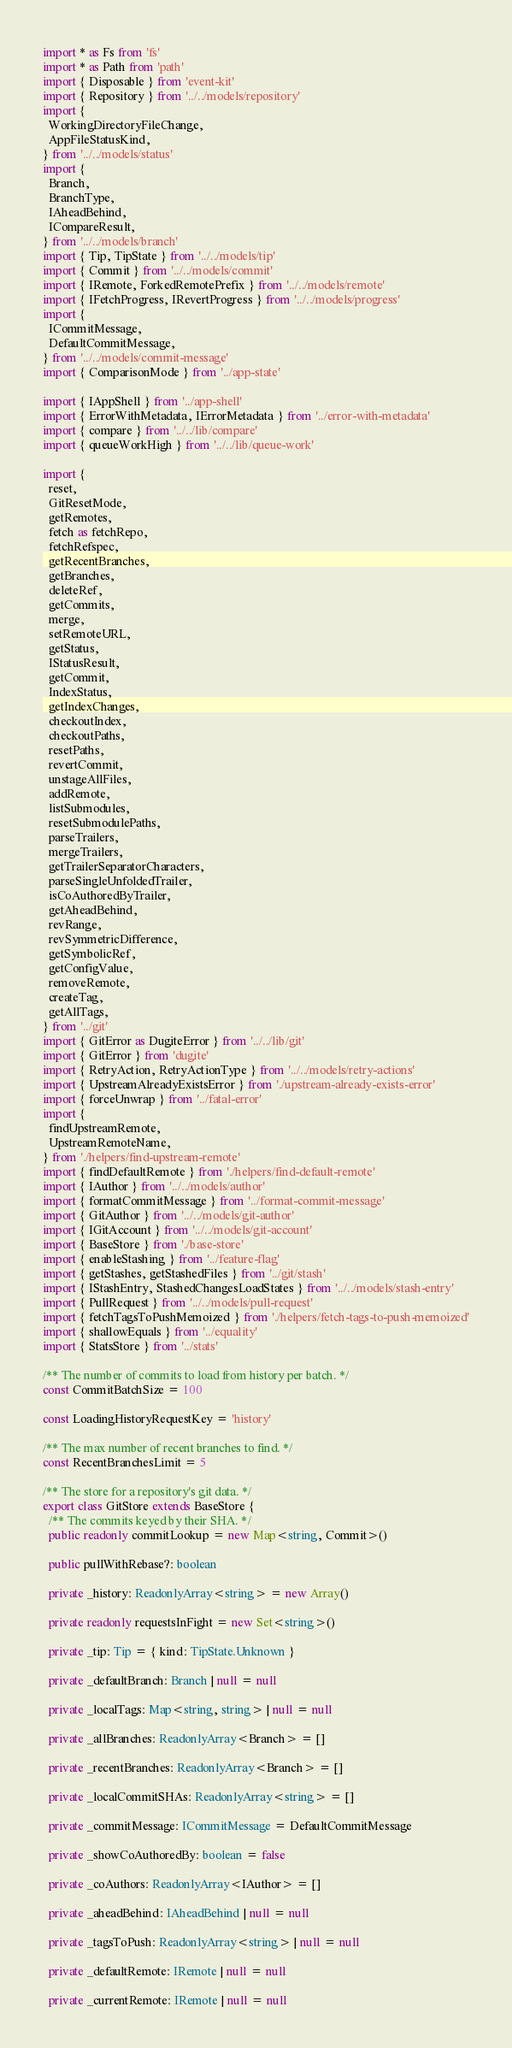<code> <loc_0><loc_0><loc_500><loc_500><_TypeScript_>import * as Fs from 'fs'
import * as Path from 'path'
import { Disposable } from 'event-kit'
import { Repository } from '../../models/repository'
import {
  WorkingDirectoryFileChange,
  AppFileStatusKind,
} from '../../models/status'
import {
  Branch,
  BranchType,
  IAheadBehind,
  ICompareResult,
} from '../../models/branch'
import { Tip, TipState } from '../../models/tip'
import { Commit } from '../../models/commit'
import { IRemote, ForkedRemotePrefix } from '../../models/remote'
import { IFetchProgress, IRevertProgress } from '../../models/progress'
import {
  ICommitMessage,
  DefaultCommitMessage,
} from '../../models/commit-message'
import { ComparisonMode } from '../app-state'

import { IAppShell } from '../app-shell'
import { ErrorWithMetadata, IErrorMetadata } from '../error-with-metadata'
import { compare } from '../../lib/compare'
import { queueWorkHigh } from '../../lib/queue-work'

import {
  reset,
  GitResetMode,
  getRemotes,
  fetch as fetchRepo,
  fetchRefspec,
  getRecentBranches,
  getBranches,
  deleteRef,
  getCommits,
  merge,
  setRemoteURL,
  getStatus,
  IStatusResult,
  getCommit,
  IndexStatus,
  getIndexChanges,
  checkoutIndex,
  checkoutPaths,
  resetPaths,
  revertCommit,
  unstageAllFiles,
  addRemote,
  listSubmodules,
  resetSubmodulePaths,
  parseTrailers,
  mergeTrailers,
  getTrailerSeparatorCharacters,
  parseSingleUnfoldedTrailer,
  isCoAuthoredByTrailer,
  getAheadBehind,
  revRange,
  revSymmetricDifference,
  getSymbolicRef,
  getConfigValue,
  removeRemote,
  createTag,
  getAllTags,
} from '../git'
import { GitError as DugiteError } from '../../lib/git'
import { GitError } from 'dugite'
import { RetryAction, RetryActionType } from '../../models/retry-actions'
import { UpstreamAlreadyExistsError } from './upstream-already-exists-error'
import { forceUnwrap } from '../fatal-error'
import {
  findUpstreamRemote,
  UpstreamRemoteName,
} from './helpers/find-upstream-remote'
import { findDefaultRemote } from './helpers/find-default-remote'
import { IAuthor } from '../../models/author'
import { formatCommitMessage } from '../format-commit-message'
import { GitAuthor } from '../../models/git-author'
import { IGitAccount } from '../../models/git-account'
import { BaseStore } from './base-store'
import { enableStashing } from '../feature-flag'
import { getStashes, getStashedFiles } from '../git/stash'
import { IStashEntry, StashedChangesLoadStates } from '../../models/stash-entry'
import { PullRequest } from '../../models/pull-request'
import { fetchTagsToPushMemoized } from './helpers/fetch-tags-to-push-memoized'
import { shallowEquals } from '../equality'
import { StatsStore } from '../stats'

/** The number of commits to load from history per batch. */
const CommitBatchSize = 100

const LoadingHistoryRequestKey = 'history'

/** The max number of recent branches to find. */
const RecentBranchesLimit = 5

/** The store for a repository's git data. */
export class GitStore extends BaseStore {
  /** The commits keyed by their SHA. */
  public readonly commitLookup = new Map<string, Commit>()

  public pullWithRebase?: boolean

  private _history: ReadonlyArray<string> = new Array()

  private readonly requestsInFight = new Set<string>()

  private _tip: Tip = { kind: TipState.Unknown }

  private _defaultBranch: Branch | null = null

  private _localTags: Map<string, string> | null = null

  private _allBranches: ReadonlyArray<Branch> = []

  private _recentBranches: ReadonlyArray<Branch> = []

  private _localCommitSHAs: ReadonlyArray<string> = []

  private _commitMessage: ICommitMessage = DefaultCommitMessage

  private _showCoAuthoredBy: boolean = false

  private _coAuthors: ReadonlyArray<IAuthor> = []

  private _aheadBehind: IAheadBehind | null = null

  private _tagsToPush: ReadonlyArray<string> | null = null

  private _defaultRemote: IRemote | null = null

  private _currentRemote: IRemote | null = null
</code> 